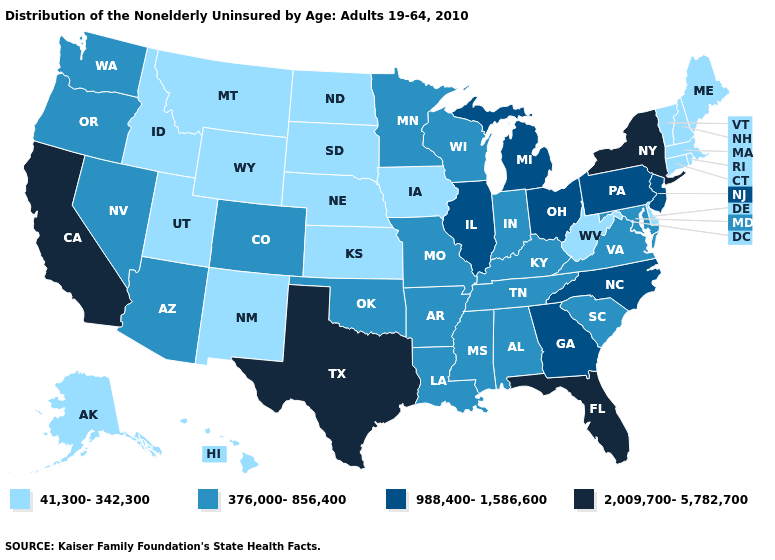What is the value of Massachusetts?
Keep it brief. 41,300-342,300. Does Oklahoma have the lowest value in the USA?
Quick response, please. No. Among the states that border Oregon , which have the lowest value?
Write a very short answer. Idaho. What is the value of New Hampshire?
Concise answer only. 41,300-342,300. Does Illinois have the same value as Michigan?
Quick response, please. Yes. Among the states that border Oklahoma , does Texas have the highest value?
Keep it brief. Yes. What is the highest value in the USA?
Answer briefly. 2,009,700-5,782,700. What is the highest value in the South ?
Answer briefly. 2,009,700-5,782,700. What is the value of Oregon?
Keep it brief. 376,000-856,400. What is the highest value in the USA?
Short answer required. 2,009,700-5,782,700. Which states have the lowest value in the USA?
Be succinct. Alaska, Connecticut, Delaware, Hawaii, Idaho, Iowa, Kansas, Maine, Massachusetts, Montana, Nebraska, New Hampshire, New Mexico, North Dakota, Rhode Island, South Dakota, Utah, Vermont, West Virginia, Wyoming. What is the highest value in the USA?
Concise answer only. 2,009,700-5,782,700. Does Texas have the highest value in the USA?
Keep it brief. Yes. Among the states that border Arizona , does Colorado have the lowest value?
Quick response, please. No. Name the states that have a value in the range 2,009,700-5,782,700?
Quick response, please. California, Florida, New York, Texas. 